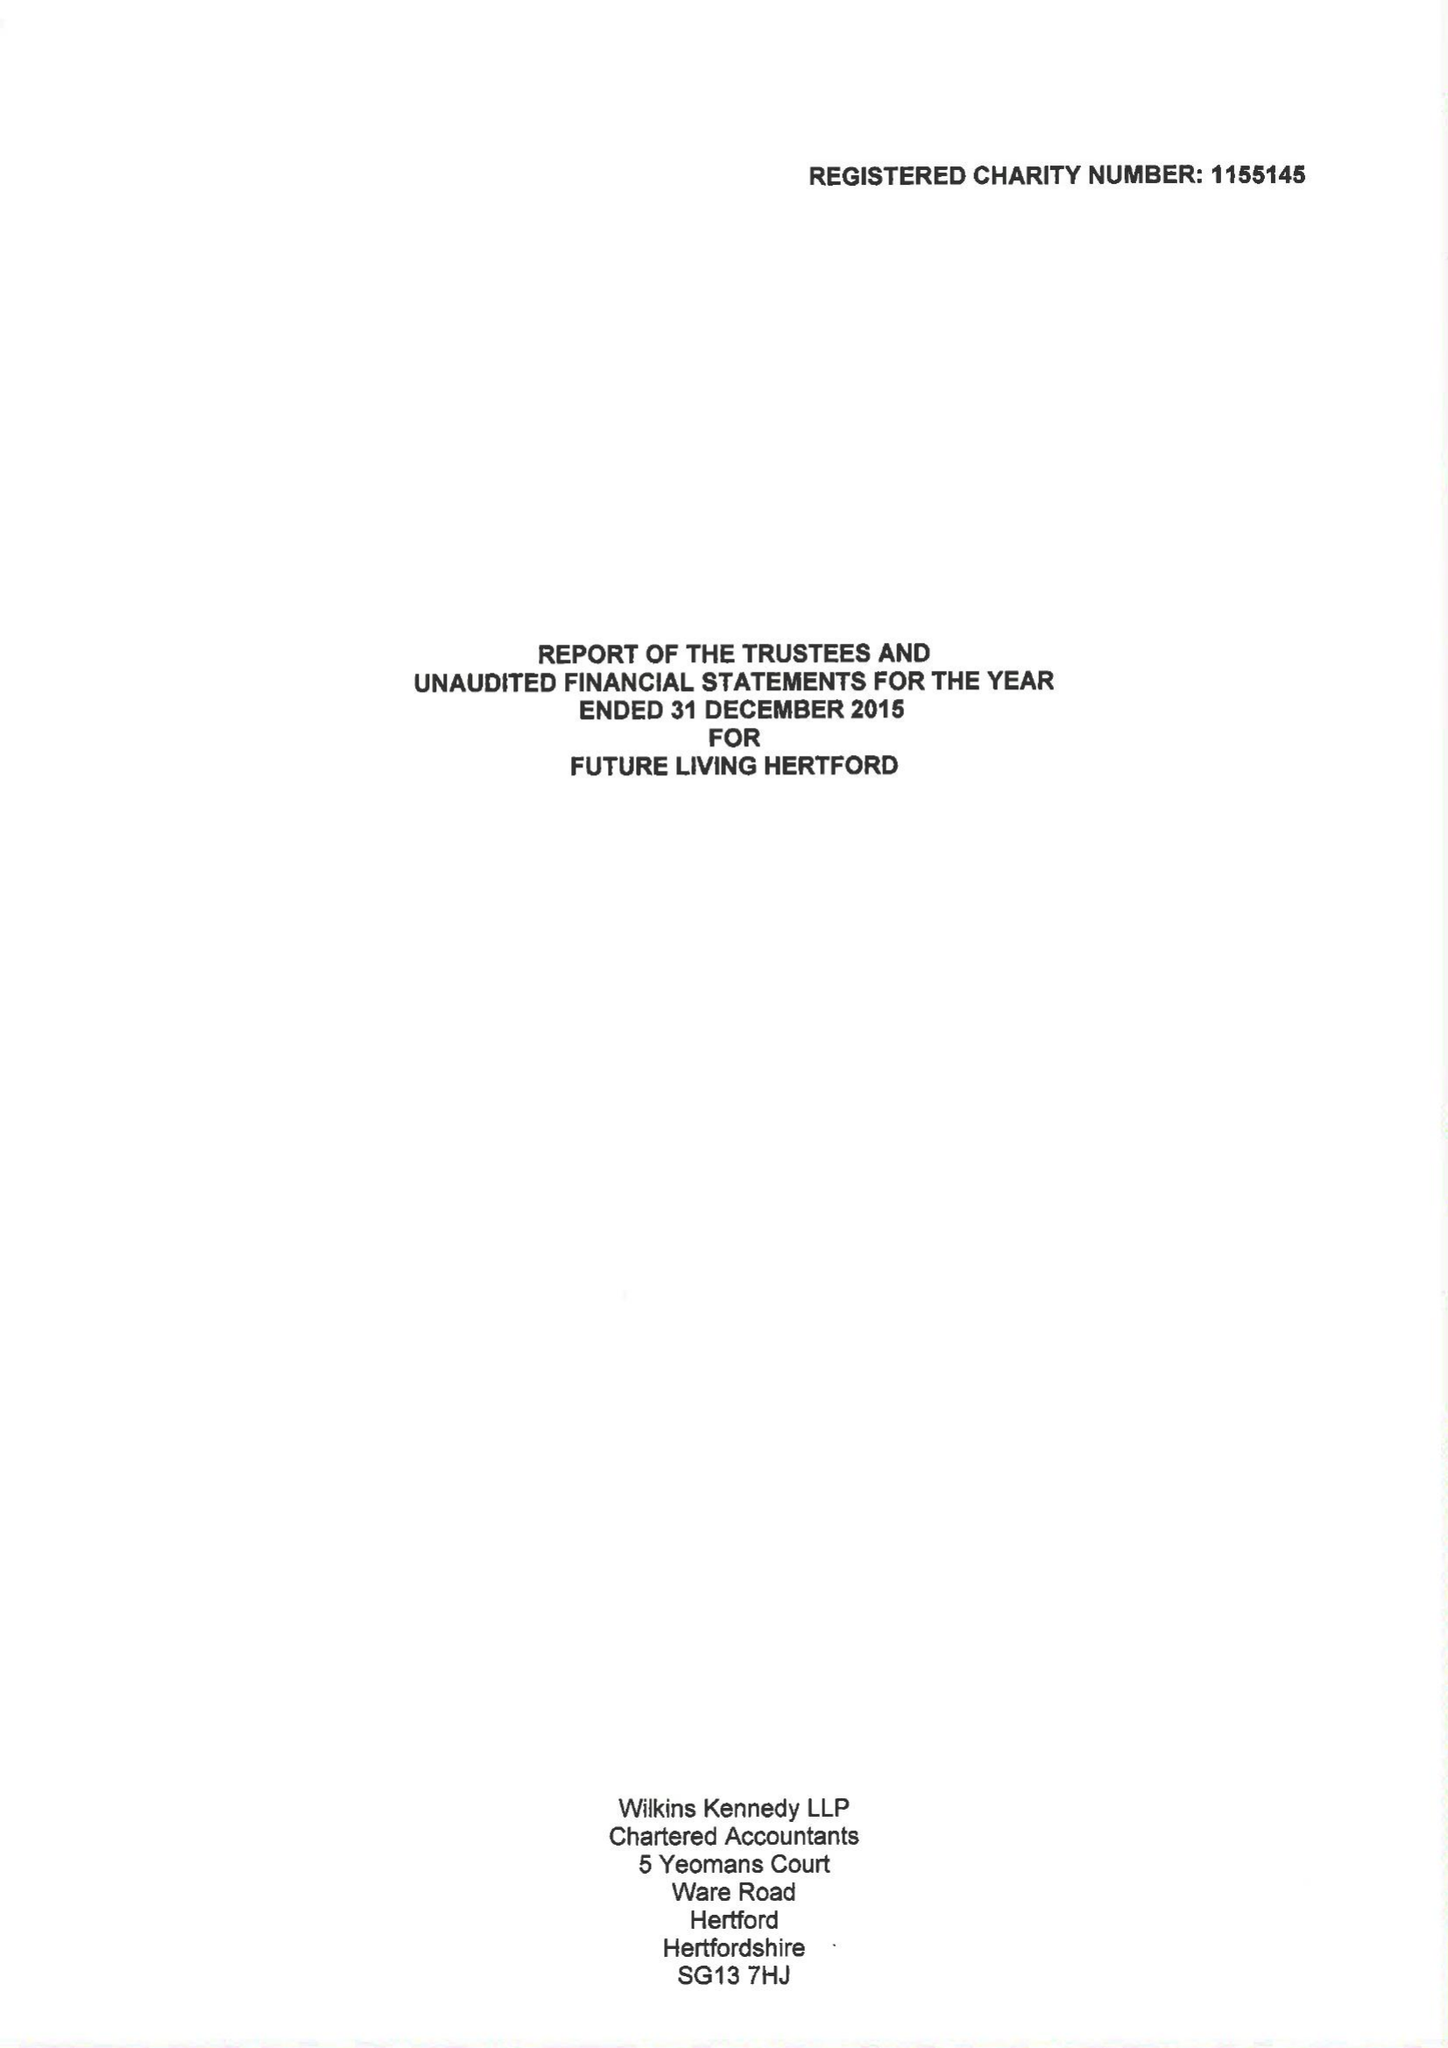What is the value for the charity_name?
Answer the question using a single word or phrase. Future Living Hertford 